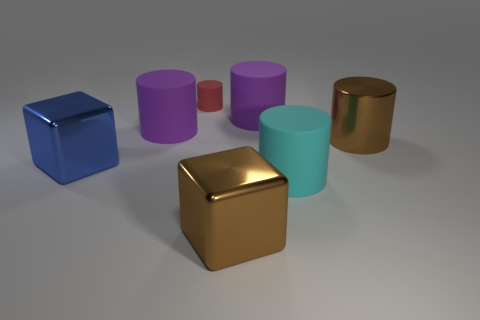How many purple cylinders must be subtracted to get 1 purple cylinders? 1 Subtract 2 cylinders. How many cylinders are left? 3 Subtract all cyan cylinders. How many cylinders are left? 4 Subtract all cyan rubber cylinders. How many cylinders are left? 4 Subtract all green cylinders. Subtract all purple spheres. How many cylinders are left? 5 Add 2 brown metallic cylinders. How many objects exist? 9 Subtract all cylinders. How many objects are left? 2 Subtract all yellow cylinders. Subtract all big brown cylinders. How many objects are left? 6 Add 5 big matte things. How many big matte things are left? 8 Add 4 purple rubber cylinders. How many purple rubber cylinders exist? 6 